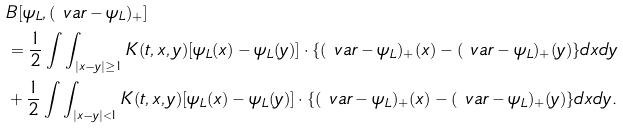Convert formula to latex. <formula><loc_0><loc_0><loc_500><loc_500>& B [ \psi _ { L } , ( \ v a r - \psi _ { L } ) _ { + } ] \\ & = \frac { 1 } { 2 } \int \int _ { | x - y | \geq 1 } K ( t , x , y ) [ \psi _ { L } ( x ) - \psi _ { L } ( y ) ] \cdot \{ ( \ v a r - \psi _ { L } ) _ { + } ( x ) - ( \ v a r - \psi _ { L } ) _ { + } ( y ) \} d x d y \\ & + \frac { 1 } { 2 } \int \int _ { | x - y | < 1 } K ( t , x , y ) [ \psi _ { L } ( x ) - \psi _ { L } ( y ) ] \cdot \{ ( \ v a r - \psi _ { L } ) _ { + } ( x ) - ( \ v a r - \psi _ { L } ) _ { + } ( y ) \} d x d y .</formula> 